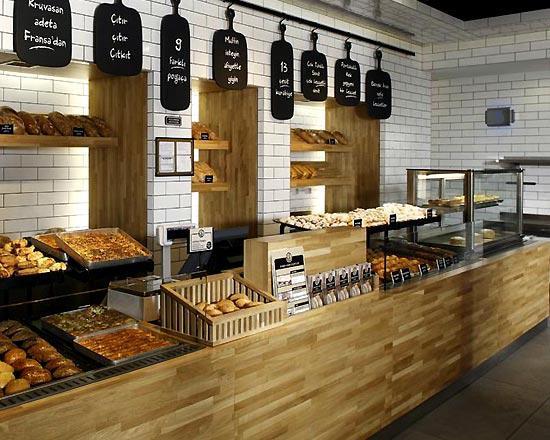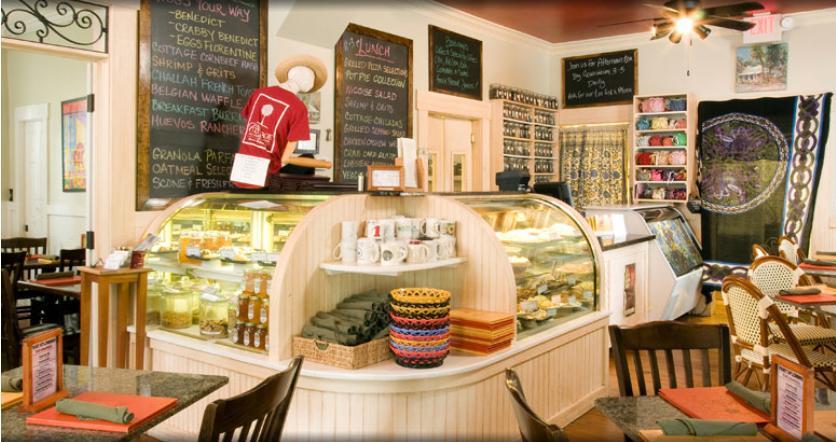The first image is the image on the left, the second image is the image on the right. For the images shown, is this caption "A bakery in one image has a seating area with tables and chairs where patrons can sit and enjoy the food and drinks they buy." true? Answer yes or no. Yes. The first image is the image on the left, the second image is the image on the right. For the images shown, is this caption "The decor of one bakery features a colorful suspended light with a round shape." true? Answer yes or no. No. 